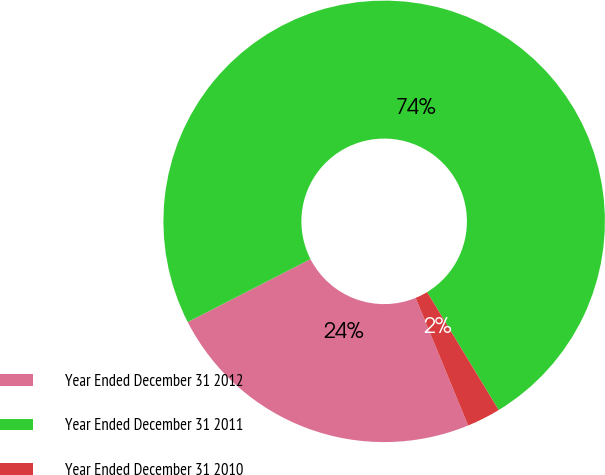Convert chart to OTSL. <chart><loc_0><loc_0><loc_500><loc_500><pie_chart><fcel>Year Ended December 31 2012<fcel>Year Ended December 31 2011<fcel>Year Ended December 31 2010<nl><fcel>23.67%<fcel>73.85%<fcel>2.47%<nl></chart> 